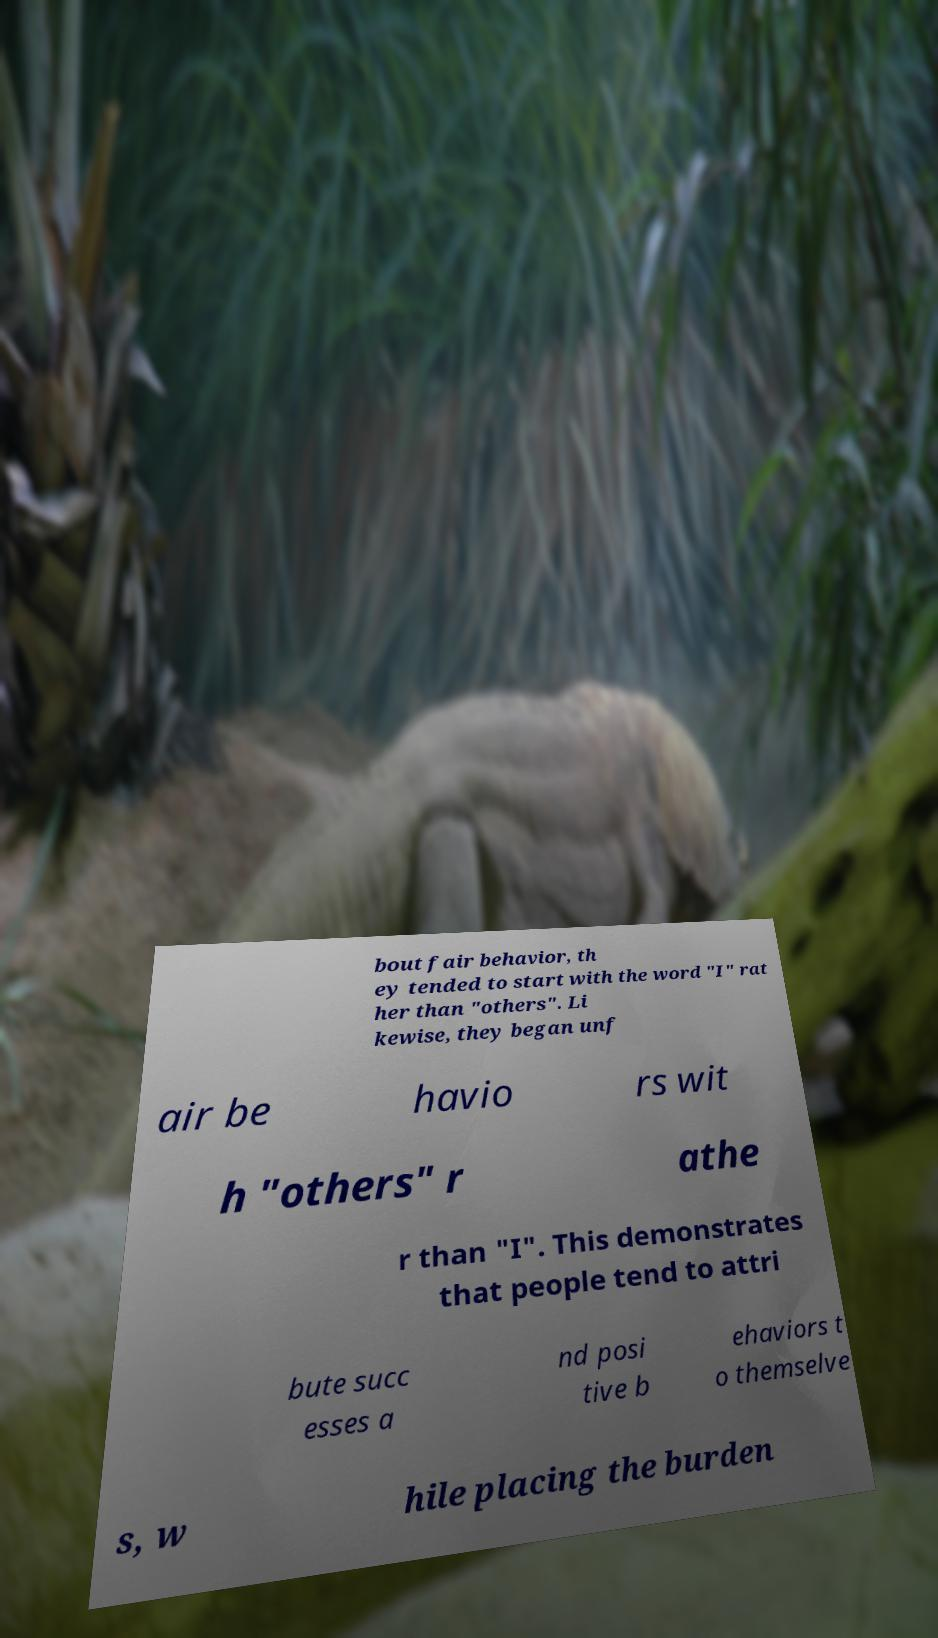Can you read and provide the text displayed in the image?This photo seems to have some interesting text. Can you extract and type it out for me? bout fair behavior, th ey tended to start with the word "I" rat her than "others". Li kewise, they began unf air be havio rs wit h "others" r athe r than "I". This demonstrates that people tend to attri bute succ esses a nd posi tive b ehaviors t o themselve s, w hile placing the burden 